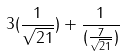Convert formula to latex. <formula><loc_0><loc_0><loc_500><loc_500>3 ( \frac { 1 } { \sqrt { 2 1 } } ) + \frac { 1 } { ( \frac { 7 } { \sqrt { 2 1 } } ) }</formula> 